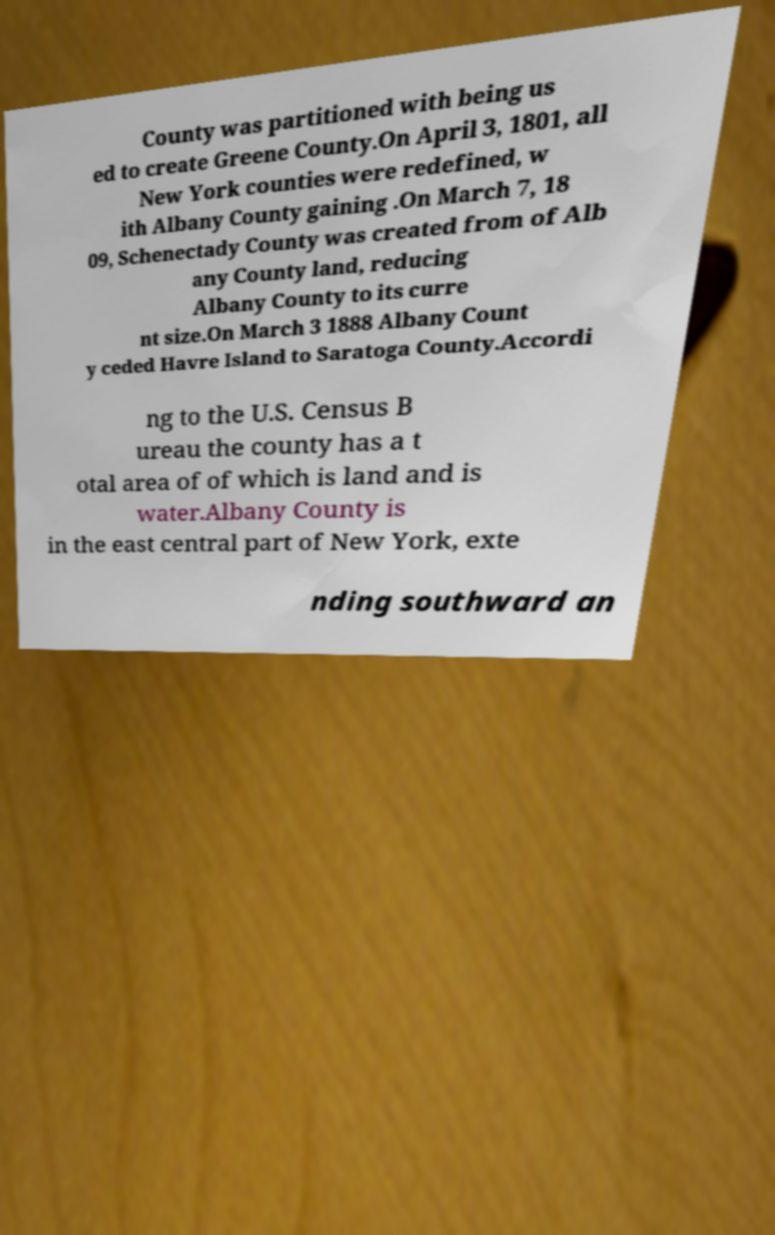Can you accurately transcribe the text from the provided image for me? County was partitioned with being us ed to create Greene County.On April 3, 1801, all New York counties were redefined, w ith Albany County gaining .On March 7, 18 09, Schenectady County was created from of Alb any County land, reducing Albany County to its curre nt size.On March 3 1888 Albany Count y ceded Havre Island to Saratoga County.Accordi ng to the U.S. Census B ureau the county has a t otal area of of which is land and is water.Albany County is in the east central part of New York, exte nding southward an 